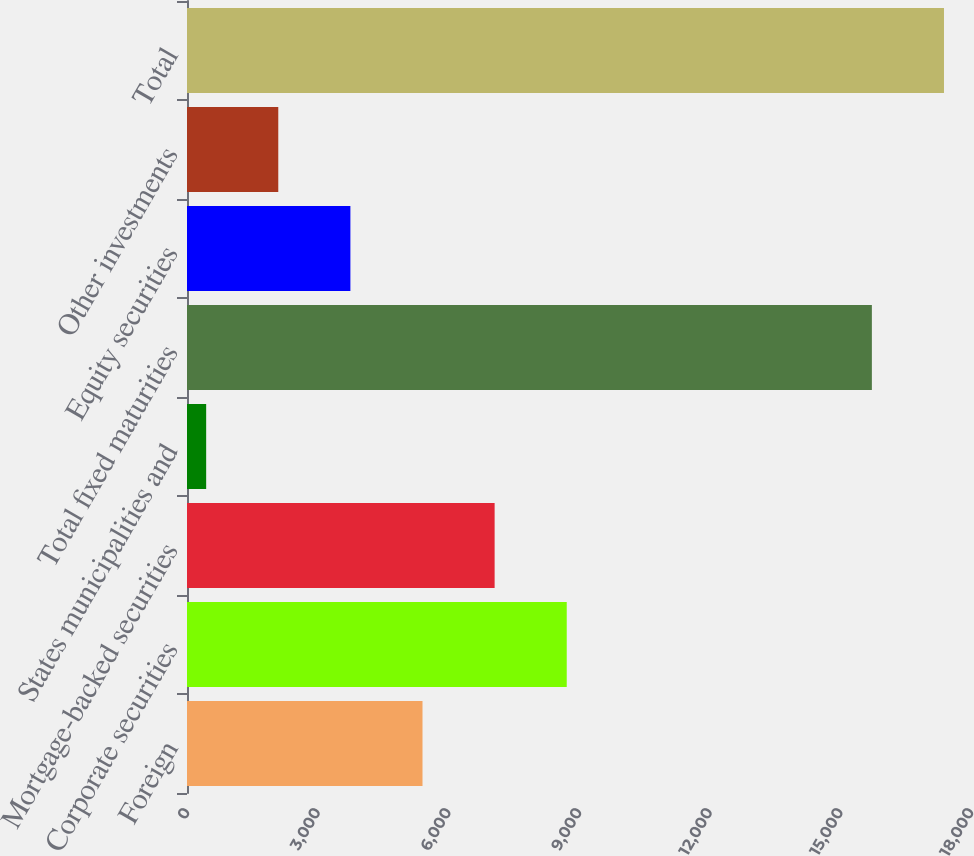Convert chart to OTSL. <chart><loc_0><loc_0><loc_500><loc_500><bar_chart><fcel>Foreign<fcel>Corporate securities<fcel>Mortgage-backed securities<fcel>States municipalities and<fcel>Total fixed maturities<fcel>Equity securities<fcel>Other investments<fcel>Total<nl><fcel>5407.1<fcel>8718.5<fcel>7062.8<fcel>440<fcel>15724<fcel>3751.4<fcel>2095.7<fcel>17379.7<nl></chart> 